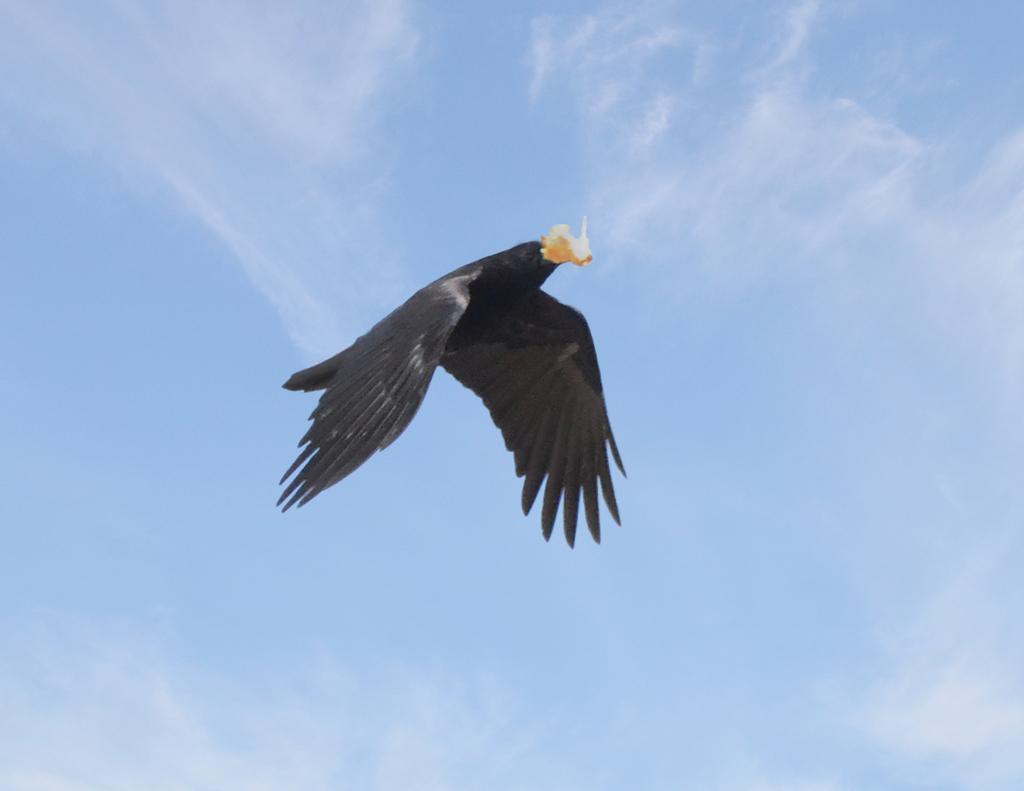Could you give a brief overview of what you see in this image? In this picture, we see a bird in black color is flying in the sky. It is holding something with its beak. In the background, we see the sky, which is blue in color. 